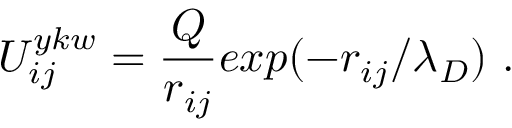<formula> <loc_0><loc_0><loc_500><loc_500>{ U _ { i j } ^ { y k w } = { \frac { Q } { r _ { i j } } } e x p ( - { r _ { i j } } / { \lambda _ { D } } ) } { . }</formula> 